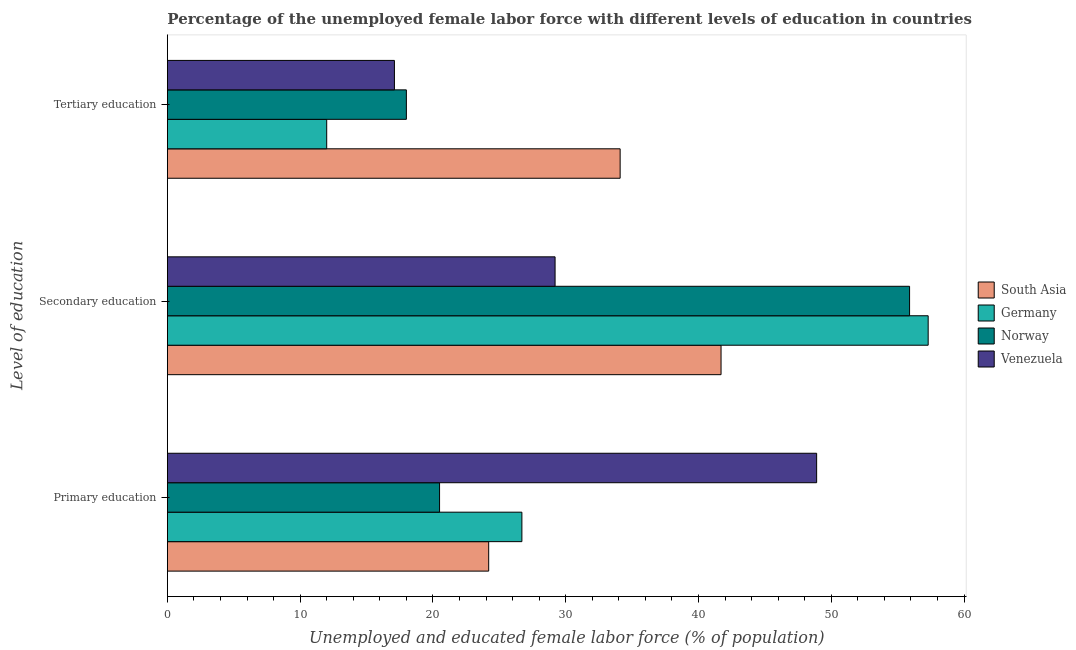How many different coloured bars are there?
Your response must be concise. 4. Are the number of bars per tick equal to the number of legend labels?
Your answer should be very brief. Yes. Are the number of bars on each tick of the Y-axis equal?
Offer a terse response. Yes. What is the label of the 3rd group of bars from the top?
Give a very brief answer. Primary education. What is the percentage of female labor force who received secondary education in Venezuela?
Offer a terse response. 29.2. Across all countries, what is the maximum percentage of female labor force who received secondary education?
Ensure brevity in your answer.  57.3. Across all countries, what is the minimum percentage of female labor force who received primary education?
Ensure brevity in your answer.  20.5. In which country was the percentage of female labor force who received secondary education minimum?
Your answer should be compact. Venezuela. What is the total percentage of female labor force who received primary education in the graph?
Your response must be concise. 120.3. What is the difference between the percentage of female labor force who received primary education in Norway and that in Venezuela?
Make the answer very short. -28.4. What is the difference between the percentage of female labor force who received primary education in Germany and the percentage of female labor force who received secondary education in South Asia?
Ensure brevity in your answer.  -15. What is the average percentage of female labor force who received primary education per country?
Make the answer very short. 30.08. What is the difference between the percentage of female labor force who received primary education and percentage of female labor force who received secondary education in Venezuela?
Your answer should be compact. 19.7. What is the ratio of the percentage of female labor force who received primary education in Norway to that in Germany?
Give a very brief answer. 0.77. Is the percentage of female labor force who received tertiary education in Venezuela less than that in Norway?
Provide a succinct answer. Yes. Is the difference between the percentage of female labor force who received secondary education in Germany and Norway greater than the difference between the percentage of female labor force who received tertiary education in Germany and Norway?
Your response must be concise. Yes. What is the difference between the highest and the second highest percentage of female labor force who received secondary education?
Make the answer very short. 1.4. What is the difference between the highest and the lowest percentage of female labor force who received secondary education?
Provide a succinct answer. 28.1. Is the sum of the percentage of female labor force who received secondary education in Germany and Norway greater than the maximum percentage of female labor force who received tertiary education across all countries?
Provide a short and direct response. Yes. What does the 4th bar from the bottom in Primary education represents?
Provide a succinct answer. Venezuela. How many countries are there in the graph?
Offer a very short reply. 4. What is the difference between two consecutive major ticks on the X-axis?
Keep it short and to the point. 10. Are the values on the major ticks of X-axis written in scientific E-notation?
Your answer should be very brief. No. Does the graph contain any zero values?
Offer a terse response. No. Does the graph contain grids?
Your answer should be compact. No. What is the title of the graph?
Provide a succinct answer. Percentage of the unemployed female labor force with different levels of education in countries. Does "Haiti" appear as one of the legend labels in the graph?
Offer a very short reply. No. What is the label or title of the X-axis?
Offer a very short reply. Unemployed and educated female labor force (% of population). What is the label or title of the Y-axis?
Offer a terse response. Level of education. What is the Unemployed and educated female labor force (% of population) in South Asia in Primary education?
Ensure brevity in your answer.  24.2. What is the Unemployed and educated female labor force (% of population) of Germany in Primary education?
Offer a terse response. 26.7. What is the Unemployed and educated female labor force (% of population) of Norway in Primary education?
Ensure brevity in your answer.  20.5. What is the Unemployed and educated female labor force (% of population) of Venezuela in Primary education?
Offer a terse response. 48.9. What is the Unemployed and educated female labor force (% of population) of South Asia in Secondary education?
Your response must be concise. 41.7. What is the Unemployed and educated female labor force (% of population) of Germany in Secondary education?
Give a very brief answer. 57.3. What is the Unemployed and educated female labor force (% of population) of Norway in Secondary education?
Your answer should be very brief. 55.9. What is the Unemployed and educated female labor force (% of population) in Venezuela in Secondary education?
Keep it short and to the point. 29.2. What is the Unemployed and educated female labor force (% of population) in South Asia in Tertiary education?
Offer a very short reply. 34.1. What is the Unemployed and educated female labor force (% of population) in Germany in Tertiary education?
Give a very brief answer. 12. What is the Unemployed and educated female labor force (% of population) in Venezuela in Tertiary education?
Your answer should be compact. 17.1. Across all Level of education, what is the maximum Unemployed and educated female labor force (% of population) in South Asia?
Keep it short and to the point. 41.7. Across all Level of education, what is the maximum Unemployed and educated female labor force (% of population) of Germany?
Keep it short and to the point. 57.3. Across all Level of education, what is the maximum Unemployed and educated female labor force (% of population) of Norway?
Your answer should be very brief. 55.9. Across all Level of education, what is the maximum Unemployed and educated female labor force (% of population) in Venezuela?
Ensure brevity in your answer.  48.9. Across all Level of education, what is the minimum Unemployed and educated female labor force (% of population) of South Asia?
Your answer should be compact. 24.2. Across all Level of education, what is the minimum Unemployed and educated female labor force (% of population) in Norway?
Your answer should be compact. 18. Across all Level of education, what is the minimum Unemployed and educated female labor force (% of population) of Venezuela?
Keep it short and to the point. 17.1. What is the total Unemployed and educated female labor force (% of population) in Germany in the graph?
Provide a short and direct response. 96. What is the total Unemployed and educated female labor force (% of population) of Norway in the graph?
Keep it short and to the point. 94.4. What is the total Unemployed and educated female labor force (% of population) of Venezuela in the graph?
Provide a succinct answer. 95.2. What is the difference between the Unemployed and educated female labor force (% of population) in South Asia in Primary education and that in Secondary education?
Offer a very short reply. -17.5. What is the difference between the Unemployed and educated female labor force (% of population) of Germany in Primary education and that in Secondary education?
Keep it short and to the point. -30.6. What is the difference between the Unemployed and educated female labor force (% of population) in Norway in Primary education and that in Secondary education?
Keep it short and to the point. -35.4. What is the difference between the Unemployed and educated female labor force (% of population) of Venezuela in Primary education and that in Secondary education?
Offer a terse response. 19.7. What is the difference between the Unemployed and educated female labor force (% of population) of Norway in Primary education and that in Tertiary education?
Ensure brevity in your answer.  2.5. What is the difference between the Unemployed and educated female labor force (% of population) in Venezuela in Primary education and that in Tertiary education?
Your answer should be compact. 31.8. What is the difference between the Unemployed and educated female labor force (% of population) in South Asia in Secondary education and that in Tertiary education?
Offer a very short reply. 7.6. What is the difference between the Unemployed and educated female labor force (% of population) in Germany in Secondary education and that in Tertiary education?
Provide a short and direct response. 45.3. What is the difference between the Unemployed and educated female labor force (% of population) of Norway in Secondary education and that in Tertiary education?
Make the answer very short. 37.9. What is the difference between the Unemployed and educated female labor force (% of population) of South Asia in Primary education and the Unemployed and educated female labor force (% of population) of Germany in Secondary education?
Your answer should be compact. -33.1. What is the difference between the Unemployed and educated female labor force (% of population) in South Asia in Primary education and the Unemployed and educated female labor force (% of population) in Norway in Secondary education?
Provide a succinct answer. -31.7. What is the difference between the Unemployed and educated female labor force (% of population) of South Asia in Primary education and the Unemployed and educated female labor force (% of population) of Venezuela in Secondary education?
Your response must be concise. -5. What is the difference between the Unemployed and educated female labor force (% of population) of Germany in Primary education and the Unemployed and educated female labor force (% of population) of Norway in Secondary education?
Ensure brevity in your answer.  -29.2. What is the difference between the Unemployed and educated female labor force (% of population) of Norway in Primary education and the Unemployed and educated female labor force (% of population) of Venezuela in Secondary education?
Give a very brief answer. -8.7. What is the difference between the Unemployed and educated female labor force (% of population) of South Asia in Primary education and the Unemployed and educated female labor force (% of population) of Norway in Tertiary education?
Your response must be concise. 6.2. What is the difference between the Unemployed and educated female labor force (% of population) of Germany in Primary education and the Unemployed and educated female labor force (% of population) of Venezuela in Tertiary education?
Your response must be concise. 9.6. What is the difference between the Unemployed and educated female labor force (% of population) of South Asia in Secondary education and the Unemployed and educated female labor force (% of population) of Germany in Tertiary education?
Offer a terse response. 29.7. What is the difference between the Unemployed and educated female labor force (% of population) of South Asia in Secondary education and the Unemployed and educated female labor force (% of population) of Norway in Tertiary education?
Give a very brief answer. 23.7. What is the difference between the Unemployed and educated female labor force (% of population) of South Asia in Secondary education and the Unemployed and educated female labor force (% of population) of Venezuela in Tertiary education?
Ensure brevity in your answer.  24.6. What is the difference between the Unemployed and educated female labor force (% of population) of Germany in Secondary education and the Unemployed and educated female labor force (% of population) of Norway in Tertiary education?
Offer a terse response. 39.3. What is the difference between the Unemployed and educated female labor force (% of population) in Germany in Secondary education and the Unemployed and educated female labor force (% of population) in Venezuela in Tertiary education?
Provide a short and direct response. 40.2. What is the difference between the Unemployed and educated female labor force (% of population) of Norway in Secondary education and the Unemployed and educated female labor force (% of population) of Venezuela in Tertiary education?
Your answer should be compact. 38.8. What is the average Unemployed and educated female labor force (% of population) of South Asia per Level of education?
Offer a very short reply. 33.33. What is the average Unemployed and educated female labor force (% of population) of Germany per Level of education?
Ensure brevity in your answer.  32. What is the average Unemployed and educated female labor force (% of population) in Norway per Level of education?
Offer a terse response. 31.47. What is the average Unemployed and educated female labor force (% of population) of Venezuela per Level of education?
Make the answer very short. 31.73. What is the difference between the Unemployed and educated female labor force (% of population) of South Asia and Unemployed and educated female labor force (% of population) of Germany in Primary education?
Keep it short and to the point. -2.5. What is the difference between the Unemployed and educated female labor force (% of population) of South Asia and Unemployed and educated female labor force (% of population) of Venezuela in Primary education?
Your response must be concise. -24.7. What is the difference between the Unemployed and educated female labor force (% of population) in Germany and Unemployed and educated female labor force (% of population) in Venezuela in Primary education?
Your answer should be very brief. -22.2. What is the difference between the Unemployed and educated female labor force (% of population) of Norway and Unemployed and educated female labor force (% of population) of Venezuela in Primary education?
Provide a short and direct response. -28.4. What is the difference between the Unemployed and educated female labor force (% of population) in South Asia and Unemployed and educated female labor force (% of population) in Germany in Secondary education?
Provide a succinct answer. -15.6. What is the difference between the Unemployed and educated female labor force (% of population) of South Asia and Unemployed and educated female labor force (% of population) of Norway in Secondary education?
Make the answer very short. -14.2. What is the difference between the Unemployed and educated female labor force (% of population) of Germany and Unemployed and educated female labor force (% of population) of Norway in Secondary education?
Make the answer very short. 1.4. What is the difference between the Unemployed and educated female labor force (% of population) in Germany and Unemployed and educated female labor force (% of population) in Venezuela in Secondary education?
Provide a short and direct response. 28.1. What is the difference between the Unemployed and educated female labor force (% of population) of Norway and Unemployed and educated female labor force (% of population) of Venezuela in Secondary education?
Provide a succinct answer. 26.7. What is the difference between the Unemployed and educated female labor force (% of population) of South Asia and Unemployed and educated female labor force (% of population) of Germany in Tertiary education?
Make the answer very short. 22.1. What is the ratio of the Unemployed and educated female labor force (% of population) in South Asia in Primary education to that in Secondary education?
Provide a short and direct response. 0.58. What is the ratio of the Unemployed and educated female labor force (% of population) of Germany in Primary education to that in Secondary education?
Provide a short and direct response. 0.47. What is the ratio of the Unemployed and educated female labor force (% of population) of Norway in Primary education to that in Secondary education?
Provide a short and direct response. 0.37. What is the ratio of the Unemployed and educated female labor force (% of population) in Venezuela in Primary education to that in Secondary education?
Give a very brief answer. 1.67. What is the ratio of the Unemployed and educated female labor force (% of population) in South Asia in Primary education to that in Tertiary education?
Your answer should be compact. 0.71. What is the ratio of the Unemployed and educated female labor force (% of population) of Germany in Primary education to that in Tertiary education?
Offer a terse response. 2.23. What is the ratio of the Unemployed and educated female labor force (% of population) in Norway in Primary education to that in Tertiary education?
Provide a succinct answer. 1.14. What is the ratio of the Unemployed and educated female labor force (% of population) of Venezuela in Primary education to that in Tertiary education?
Provide a succinct answer. 2.86. What is the ratio of the Unemployed and educated female labor force (% of population) of South Asia in Secondary education to that in Tertiary education?
Your response must be concise. 1.22. What is the ratio of the Unemployed and educated female labor force (% of population) of Germany in Secondary education to that in Tertiary education?
Your response must be concise. 4.78. What is the ratio of the Unemployed and educated female labor force (% of population) in Norway in Secondary education to that in Tertiary education?
Your answer should be compact. 3.11. What is the ratio of the Unemployed and educated female labor force (% of population) of Venezuela in Secondary education to that in Tertiary education?
Ensure brevity in your answer.  1.71. What is the difference between the highest and the second highest Unemployed and educated female labor force (% of population) in Germany?
Your answer should be compact. 30.6. What is the difference between the highest and the second highest Unemployed and educated female labor force (% of population) in Norway?
Ensure brevity in your answer.  35.4. What is the difference between the highest and the lowest Unemployed and educated female labor force (% of population) of Germany?
Offer a terse response. 45.3. What is the difference between the highest and the lowest Unemployed and educated female labor force (% of population) of Norway?
Give a very brief answer. 37.9. What is the difference between the highest and the lowest Unemployed and educated female labor force (% of population) of Venezuela?
Make the answer very short. 31.8. 